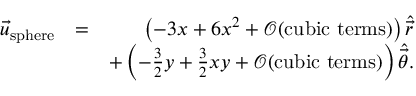<formula> <loc_0><loc_0><loc_500><loc_500>\begin{array} { r l r } { \vec { u } _ { s p h e r e } } & { = } & { \left ( - 3 x + 6 x ^ { 2 } + \mathcal { O } ( c u b i c t e r m s ) \right ) \hat { \vec { r } } } \\ & { + \left ( - \frac { 3 } { 2 } y + \frac { 3 } { 2 } x y + \mathcal { O } ( c u b i c t e r m s ) \right ) \hat { \vec { \theta } } . } \end{array}</formula> 